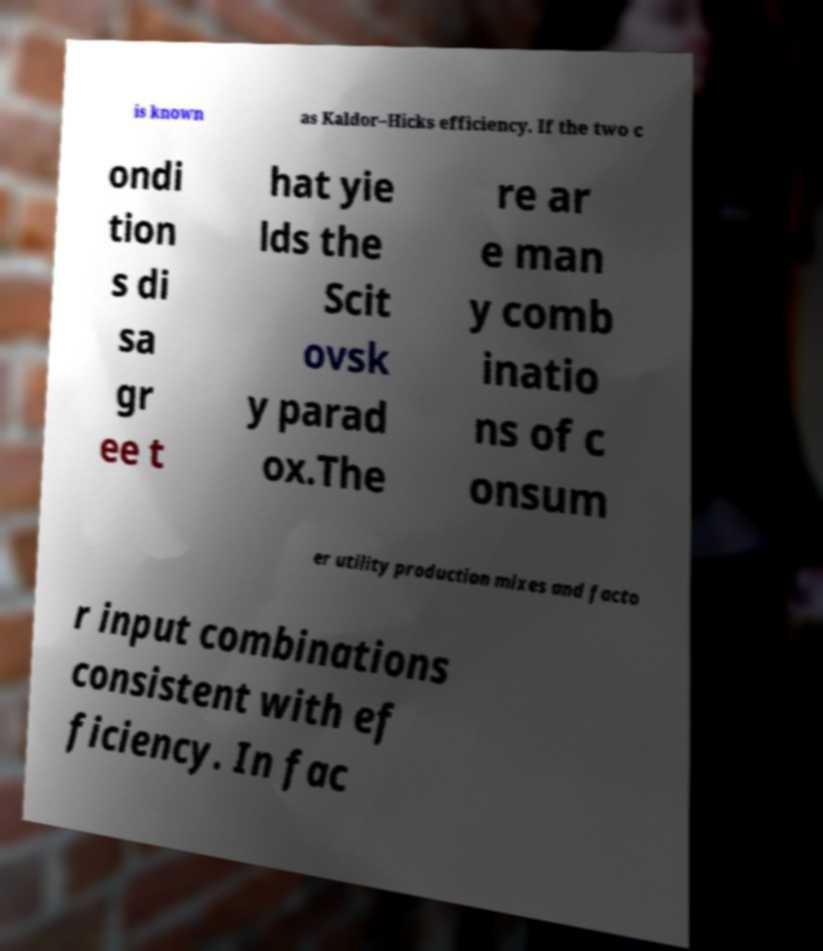Can you accurately transcribe the text from the provided image for me? is known as Kaldor–Hicks efficiency. If the two c ondi tion s di sa gr ee t hat yie lds the Scit ovsk y parad ox.The re ar e man y comb inatio ns of c onsum er utility production mixes and facto r input combinations consistent with ef ficiency. In fac 